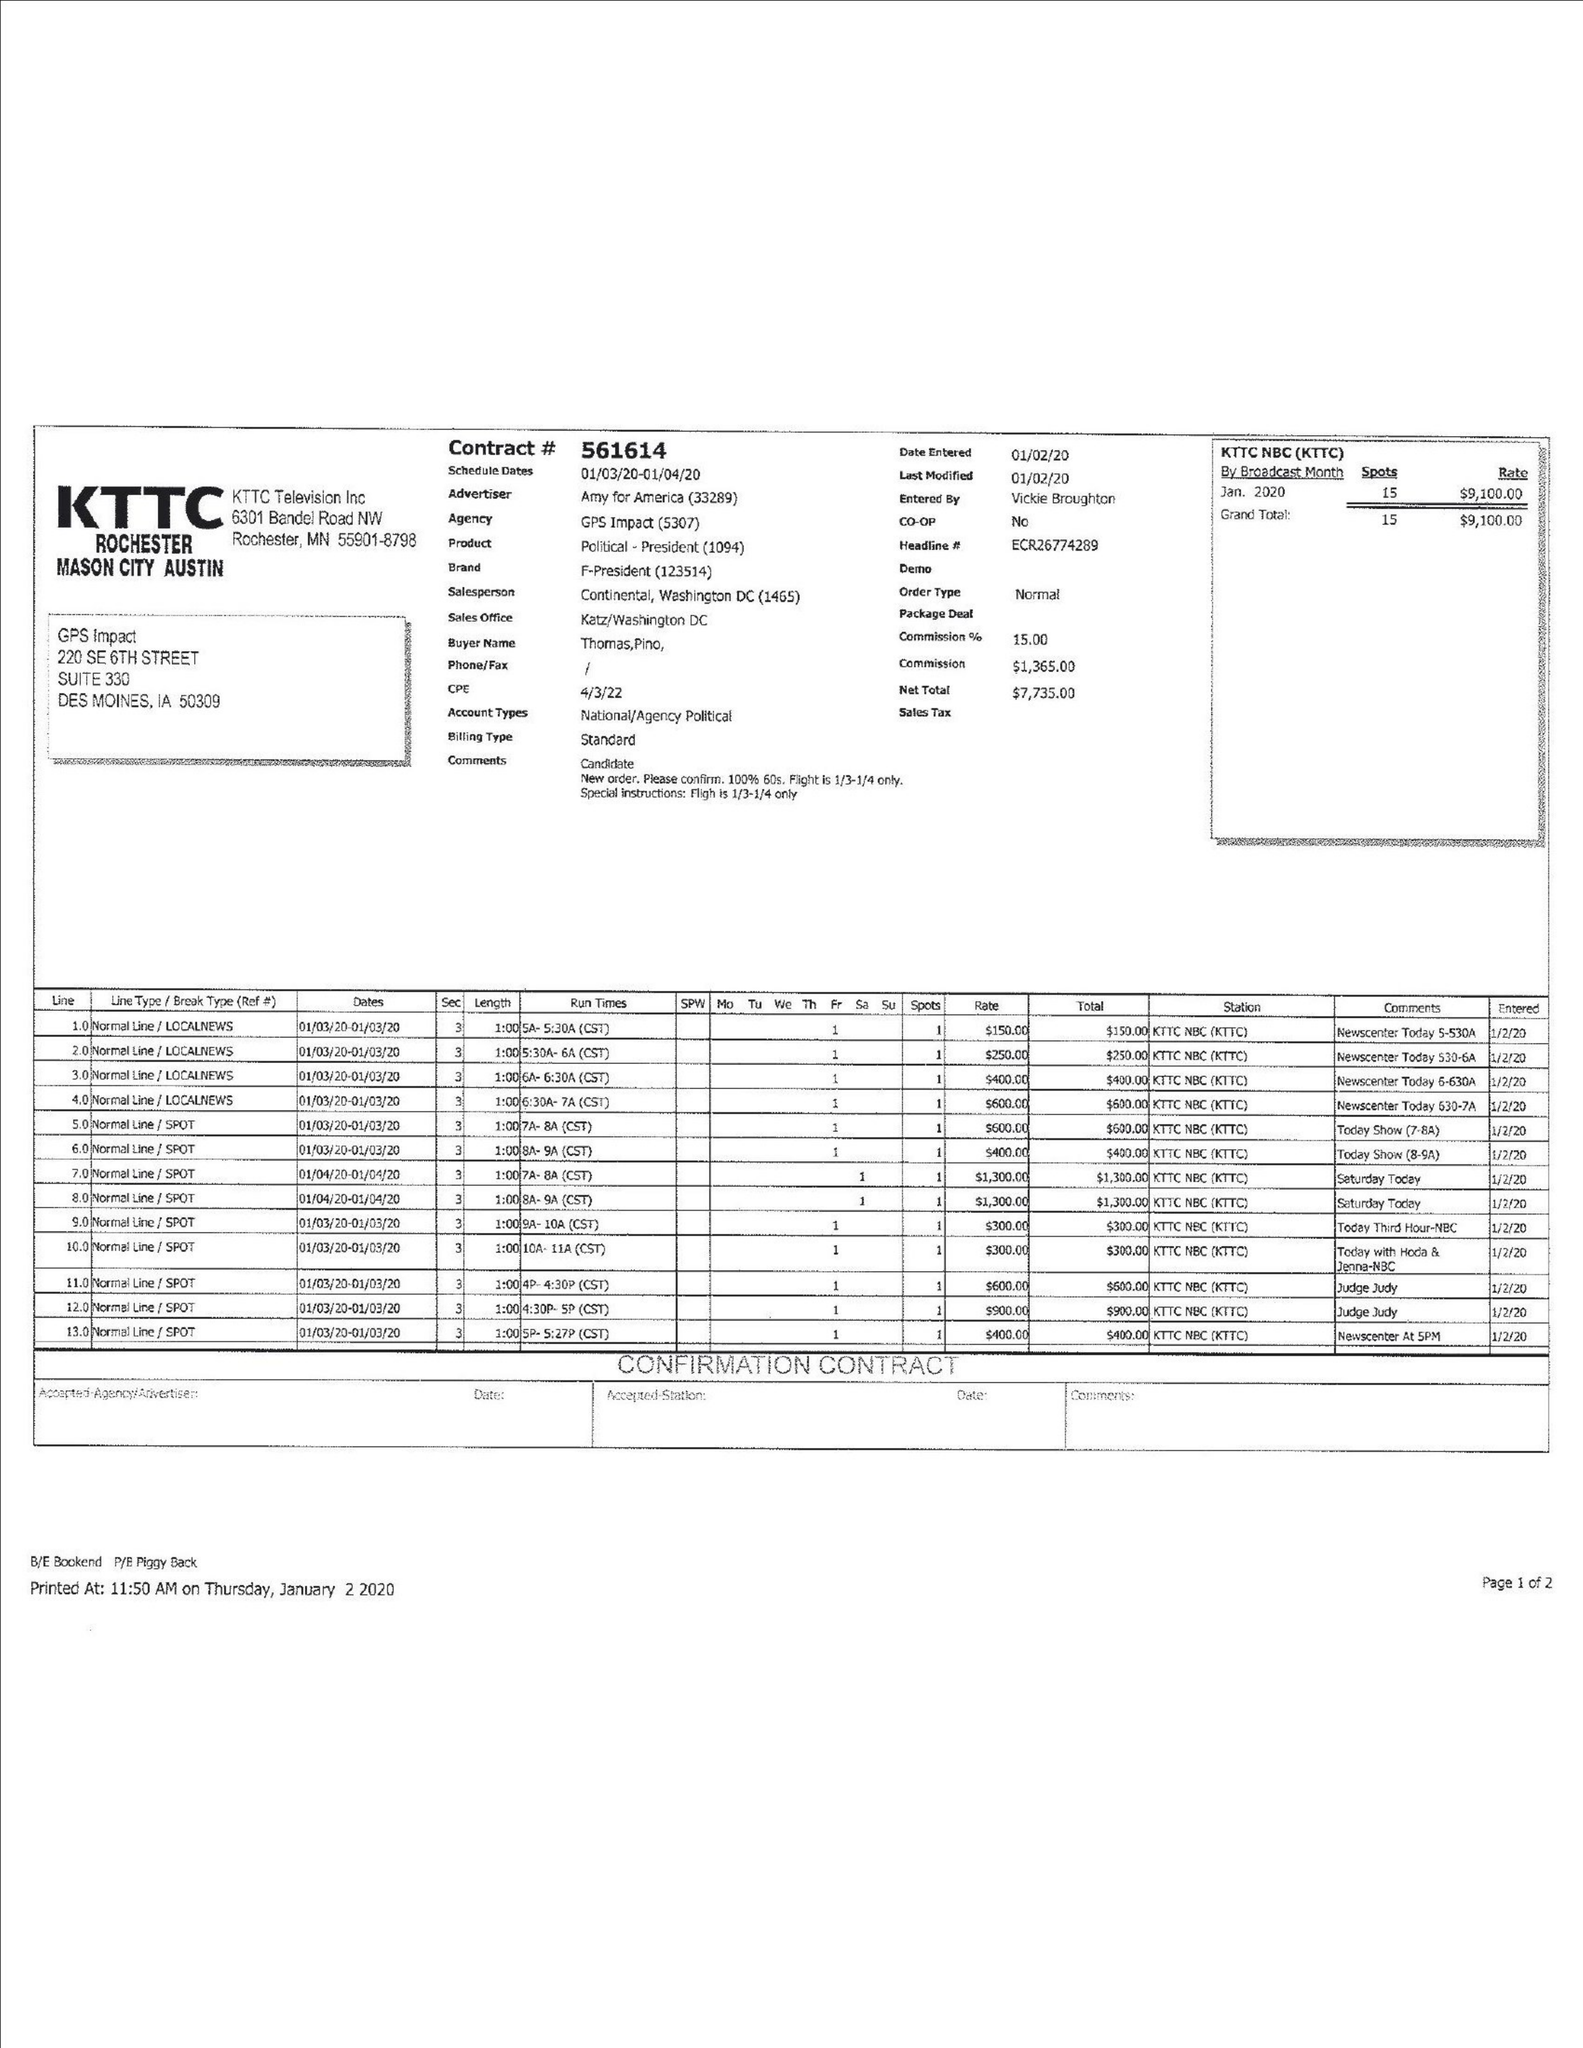What is the value for the advertiser?
Answer the question using a single word or phrase. AMY FOR AMERICA 